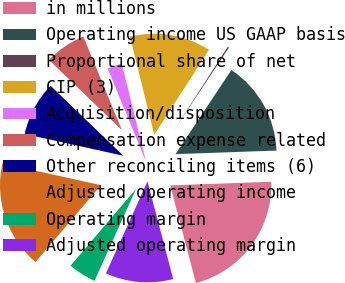<chart> <loc_0><loc_0><loc_500><loc_500><pie_chart><fcel>in millions<fcel>Operating income US GAAP basis<fcel>Proportional share of net<fcel>CIP (3)<fcel>Acquisition/disposition<fcel>Compensation expense related<fcel>Other reconciling items (6)<fcel>Adjusted operating income<fcel>Operating margin<fcel>Adjusted operating margin<nl><fcel>21.47%<fcel>15.1%<fcel>0.23%<fcel>12.97%<fcel>2.35%<fcel>6.6%<fcel>8.73%<fcel>17.22%<fcel>4.48%<fcel>10.85%<nl></chart> 